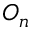Convert formula to latex. <formula><loc_0><loc_0><loc_500><loc_500>O _ { n }</formula> 